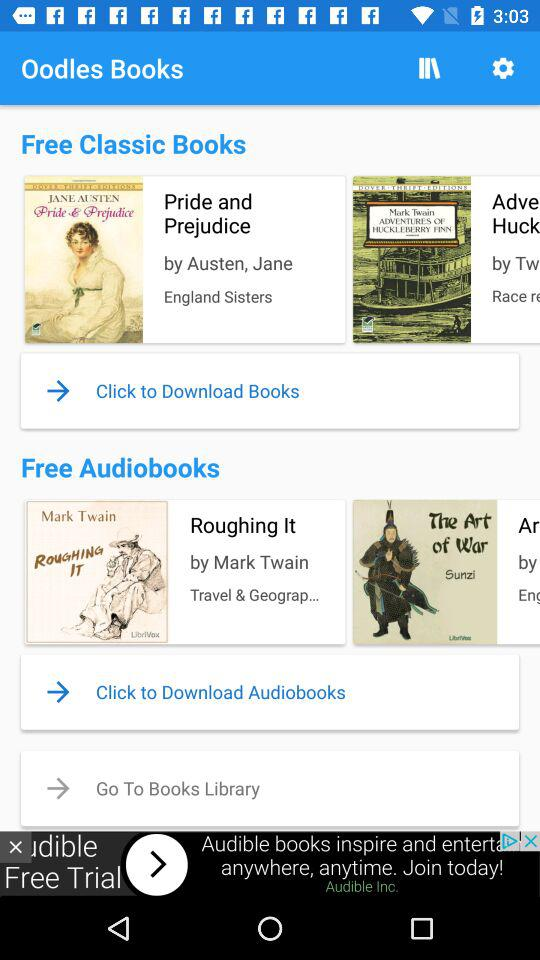Who are Austen and Jane?
When the provided information is insufficient, respond with <no answer>. <no answer> 